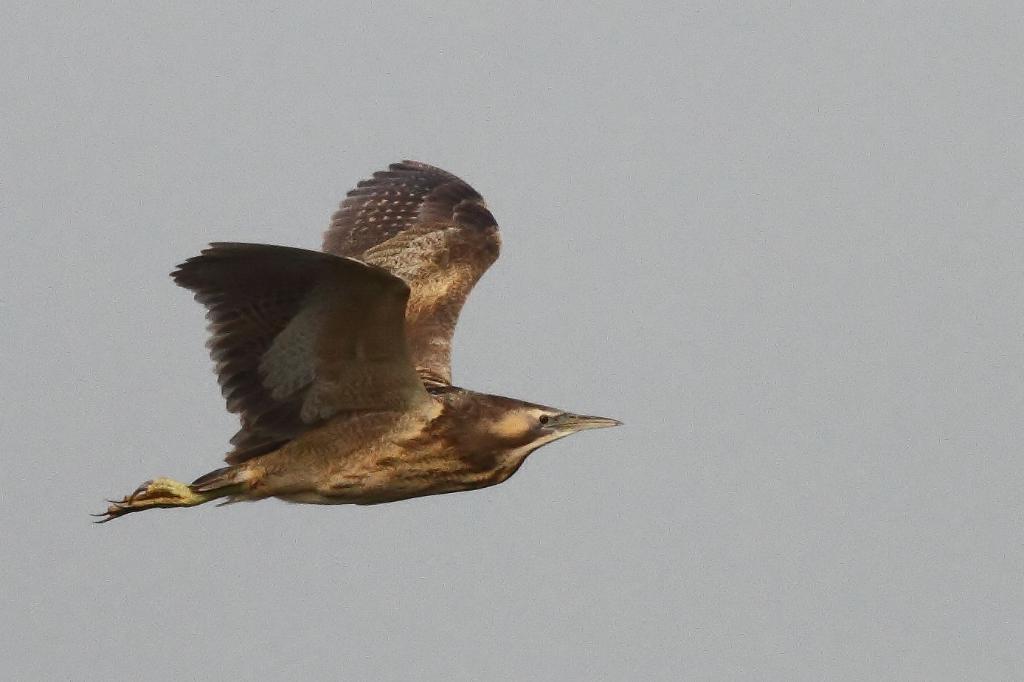Could you give a brief overview of what you see in this image? A bird is flying in the sky towards the right side. 